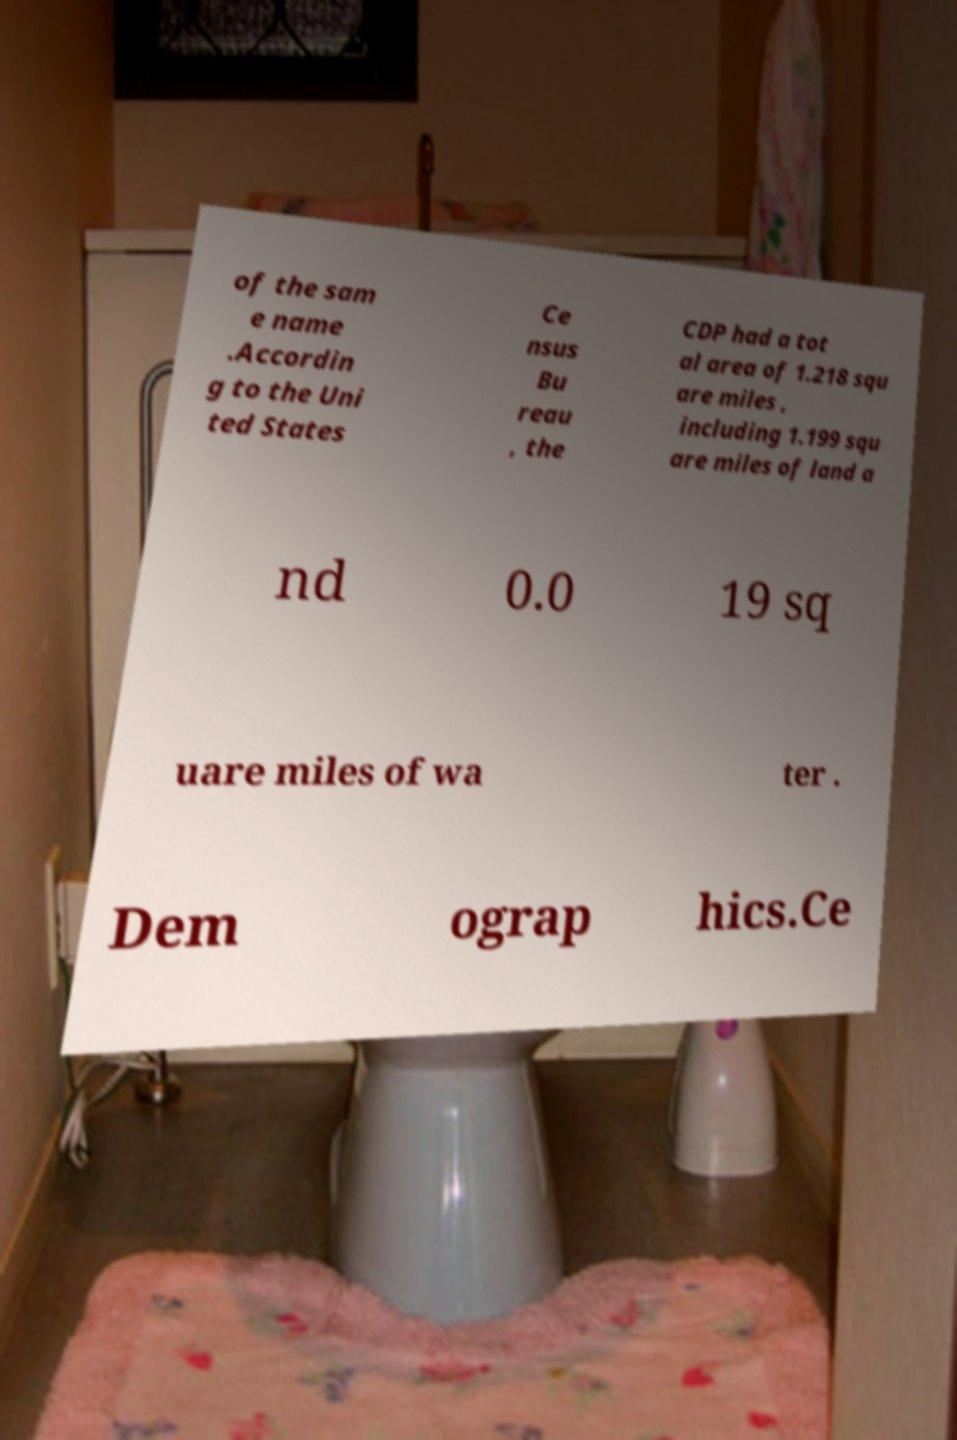Please read and relay the text visible in this image. What does it say? of the sam e name .Accordin g to the Uni ted States Ce nsus Bu reau , the CDP had a tot al area of 1.218 squ are miles , including 1.199 squ are miles of land a nd 0.0 19 sq uare miles of wa ter . Dem ograp hics.Ce 